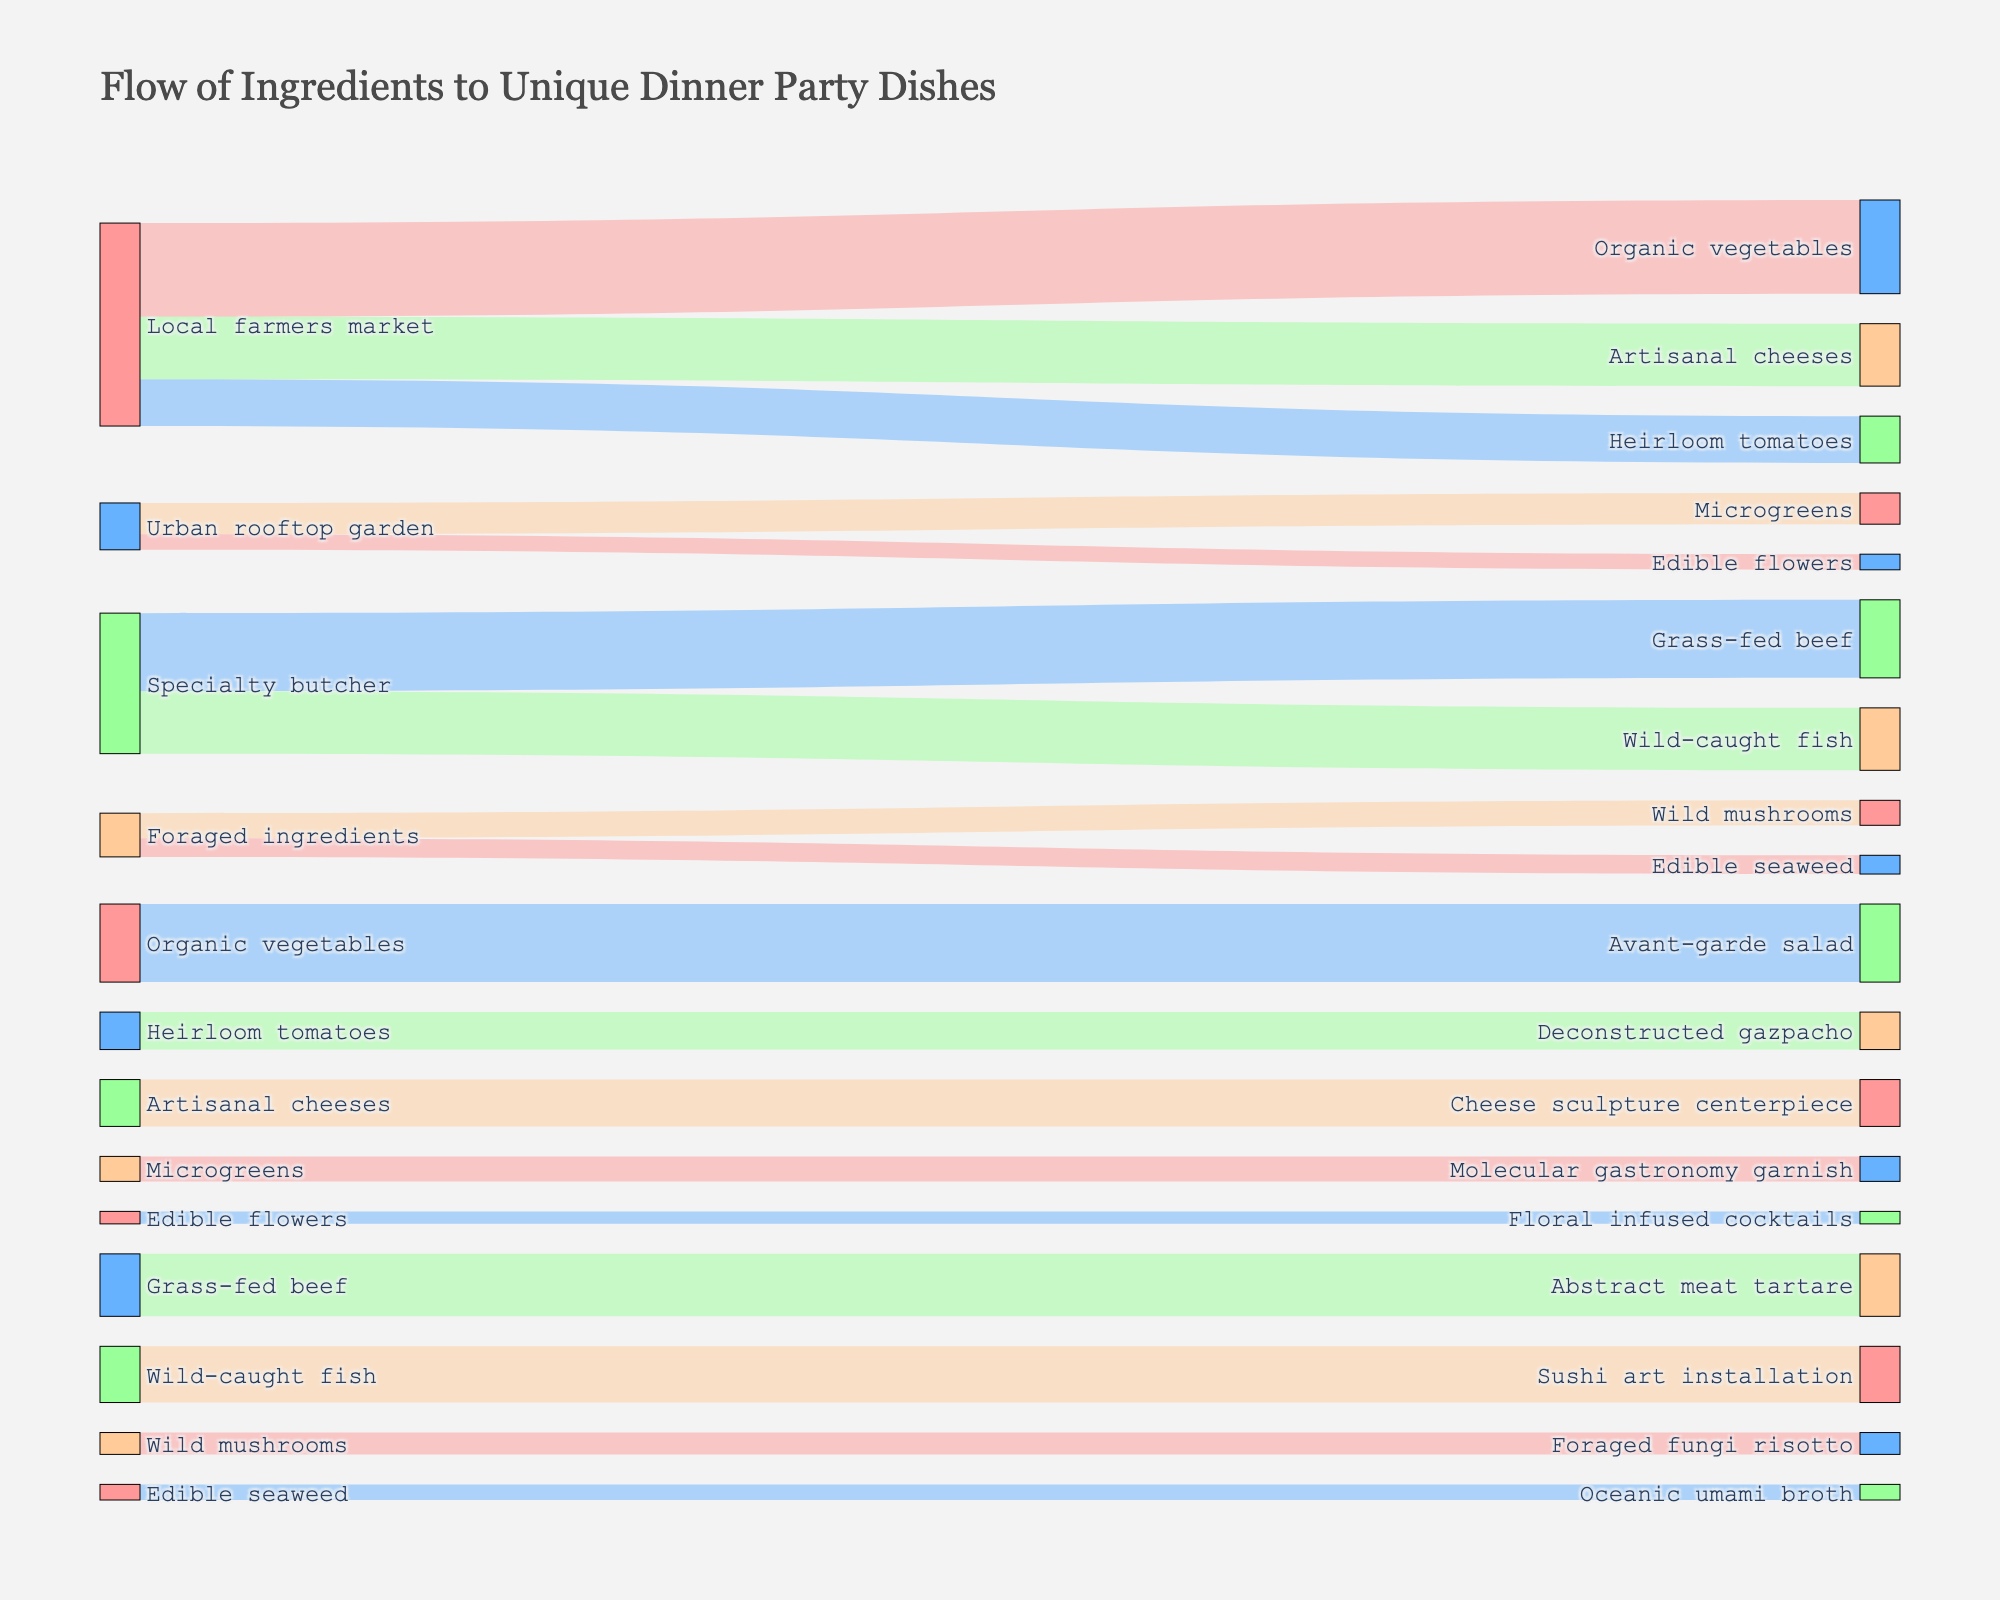What sources contribute ingredients for the Avant-garde salad? The sources connected to the "Avant-garde salad" can be identified by finding the lines leading to it. According to the figure, "Local farmers market" supplies "Organic vegetables," which then flows to the "Avant-garde salad."
Answer: Local farmers market What is the total quantity of ingredients sourced from the Local farmers market? To find this, add up the values for all targets connected to "Local farmers market": 30 (Organic vegetables) + 15 (Heirloom tomatoes) + 20 (Artisanal cheeses) = 65.
Answer: 65 Which dishes utilize ingredients from Foraged ingredients? Look for the targets associated with the source "Foraged ingredients." These are "Wild mushrooms" and "Edible seaweed," which ultimately go into "Foraged fungi risotto" and "Oceanic umami broth," respectively.
Answer: Foraged fungi risotto and Oceanic umami broth How many categories of sources are there in the diagram? Count the unique source nodes displayed on the figure. The sources include "Local farmers market," "Urban rooftop garden," "Specialty butcher," and "Foraged ingredients."
Answer: 4 From which sources do dishes with floral ingredients come? Locate dishes with floral ingredients like "Floral infused cocktails." Trace its ingredient, "Edible flowers," back to its source, which is the "Urban rooftop garden."
Answer: Urban rooftop garden What is the sum of quantities of all ingredients sourced from the Urban rooftop garden? Add the values for all targets connected to "Urban rooftop garden": 10 (Microgreens) + 5 (Edible flowers) = 15.
Answer: 15 Which target dish receives the least amount of ingredients, and how much? Review the values associated with each dish. "Floral infused cocktails" receives the least with a value of 4.
Answer: Floral infused cocktails, 4 Which sourced ingredient is used in making the Abstract meat tartare? From the figure, observe the flow leading to "Abstract meat tartare." The ingredient is "Grass-fed beef" sourced from the "Specialty butcher."
Answer: Grass-fed beef What is the total amount of ingredients supplied by the Specialty butcher? Add the values for all targets connected to "Specialty butcher": 25 (Grass-fed beef) + 20 (Wild-caught fish) = 45.
Answer: 45 